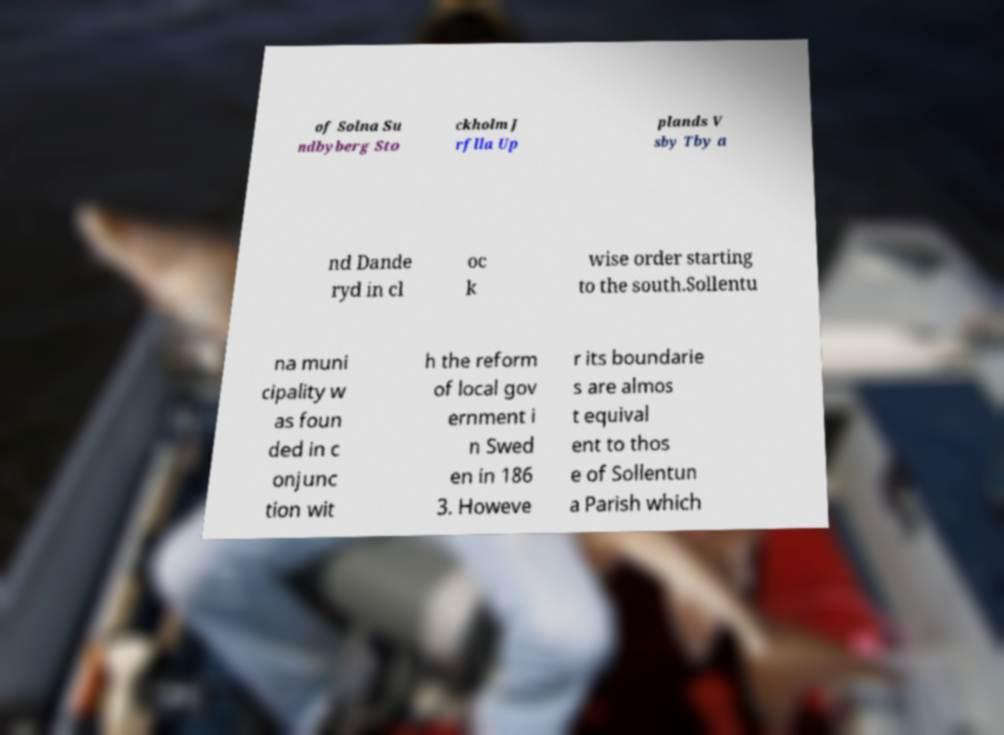For documentation purposes, I need the text within this image transcribed. Could you provide that? of Solna Su ndbyberg Sto ckholm J rflla Up plands V sby Tby a nd Dande ryd in cl oc k wise order starting to the south.Sollentu na muni cipality w as foun ded in c onjunc tion wit h the reform of local gov ernment i n Swed en in 186 3. Howeve r its boundarie s are almos t equival ent to thos e of Sollentun a Parish which 